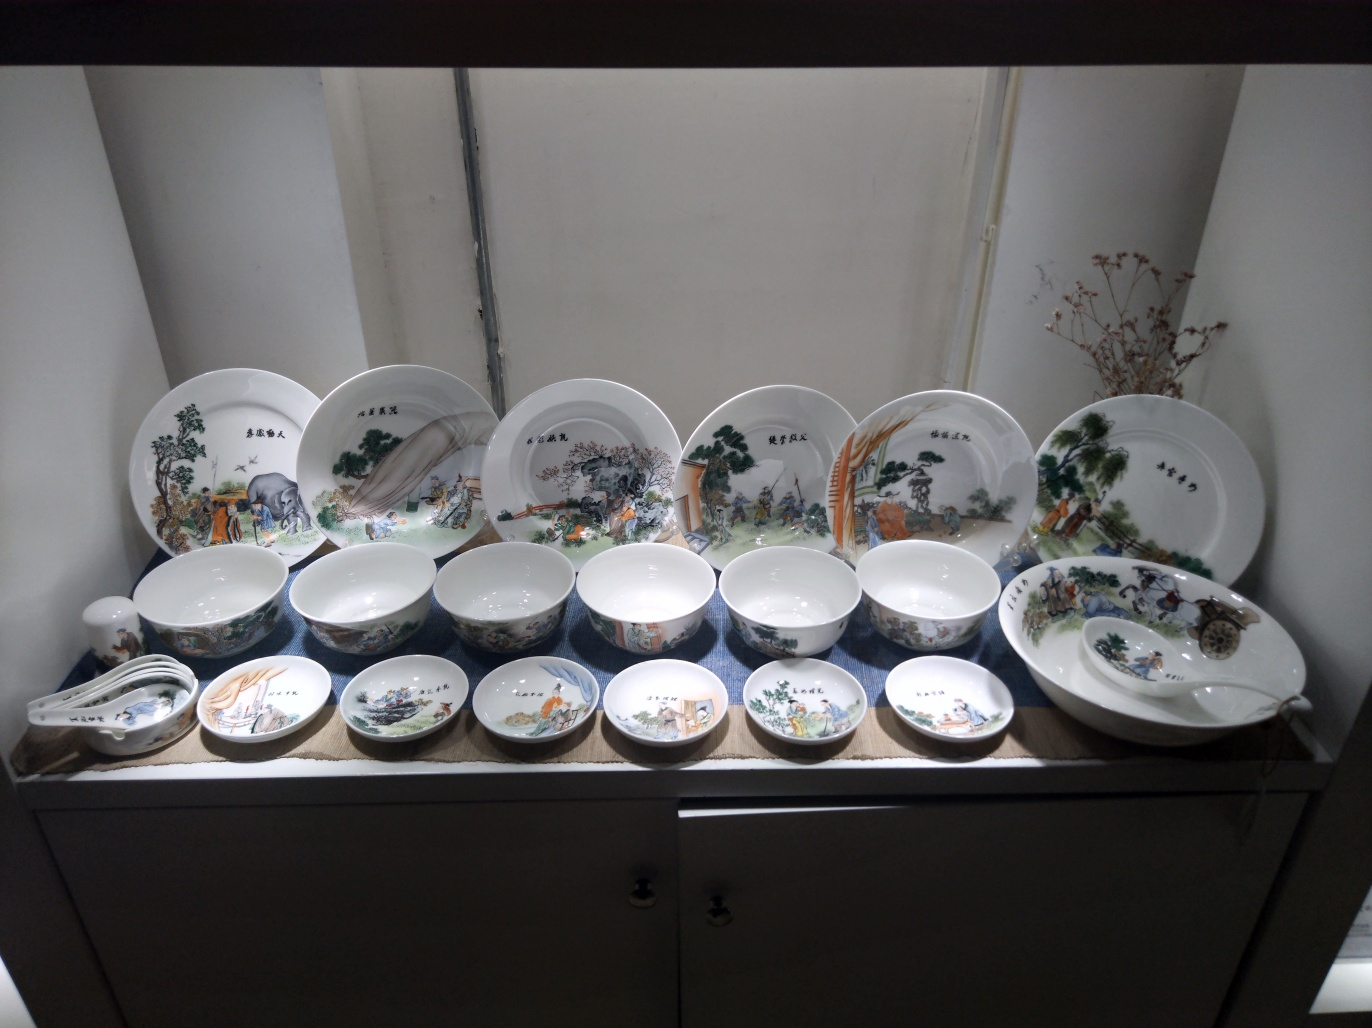Does the photo have a sense of classical beauty? Yes, the photo embodies a sense of classical beauty. The collection of elaborately decorated porcelain dishware exudes an air of traditional elegance and historical craftsmanship. Each piece is adorned with intricate, pastoral imagery that is reminiscent of classical artistic styles, evoking a sense of timelessness and attention to detail. The meticulous artistry and symmetry in the arrangement contribute to the overall classical aesthetic of the scene. 